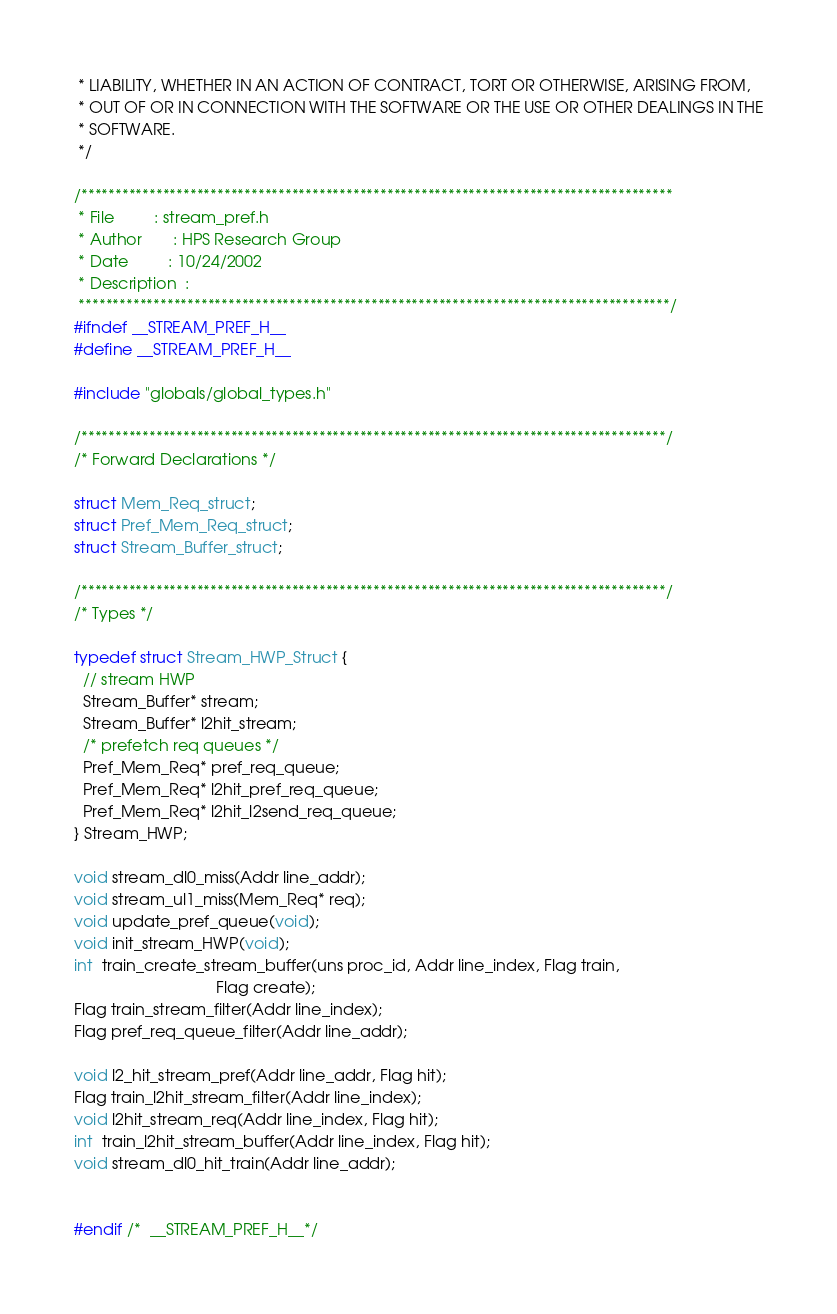Convert code to text. <code><loc_0><loc_0><loc_500><loc_500><_C_> * LIABILITY, WHETHER IN AN ACTION OF CONTRACT, TORT OR OTHERWISE, ARISING FROM,
 * OUT OF OR IN CONNECTION WITH THE SOFTWARE OR THE USE OR OTHER DEALINGS IN THE
 * SOFTWARE.
 */

/***************************************************************************************
 * File         : stream_pref.h
 * Author       : HPS Research Group
 * Date         : 10/24/2002
 * Description  :
 ***************************************************************************************/
#ifndef __STREAM_PREF_H__
#define __STREAM_PREF_H__

#include "globals/global_types.h"

/**************************************************************************************/
/* Forward Declarations */

struct Mem_Req_struct;
struct Pref_Mem_Req_struct;
struct Stream_Buffer_struct;

/**************************************************************************************/
/* Types */

typedef struct Stream_HWP_Struct {
  // stream HWP
  Stream_Buffer* stream;
  Stream_Buffer* l2hit_stream;
  /* prefetch req queues */
  Pref_Mem_Req* pref_req_queue;
  Pref_Mem_Req* l2hit_pref_req_queue;
  Pref_Mem_Req* l2hit_l2send_req_queue;
} Stream_HWP;

void stream_dl0_miss(Addr line_addr);
void stream_ul1_miss(Mem_Req* req);
void update_pref_queue(void);
void init_stream_HWP(void);
int  train_create_stream_buffer(uns proc_id, Addr line_index, Flag train,
                                Flag create);
Flag train_stream_filter(Addr line_index);
Flag pref_req_queue_filter(Addr line_addr);

void l2_hit_stream_pref(Addr line_addr, Flag hit);
Flag train_l2hit_stream_filter(Addr line_index);
void l2hit_stream_req(Addr line_index, Flag hit);
int  train_l2hit_stream_buffer(Addr line_index, Flag hit);
void stream_dl0_hit_train(Addr line_addr);


#endif /*  __STREAM_PREF_H__*/
</code> 